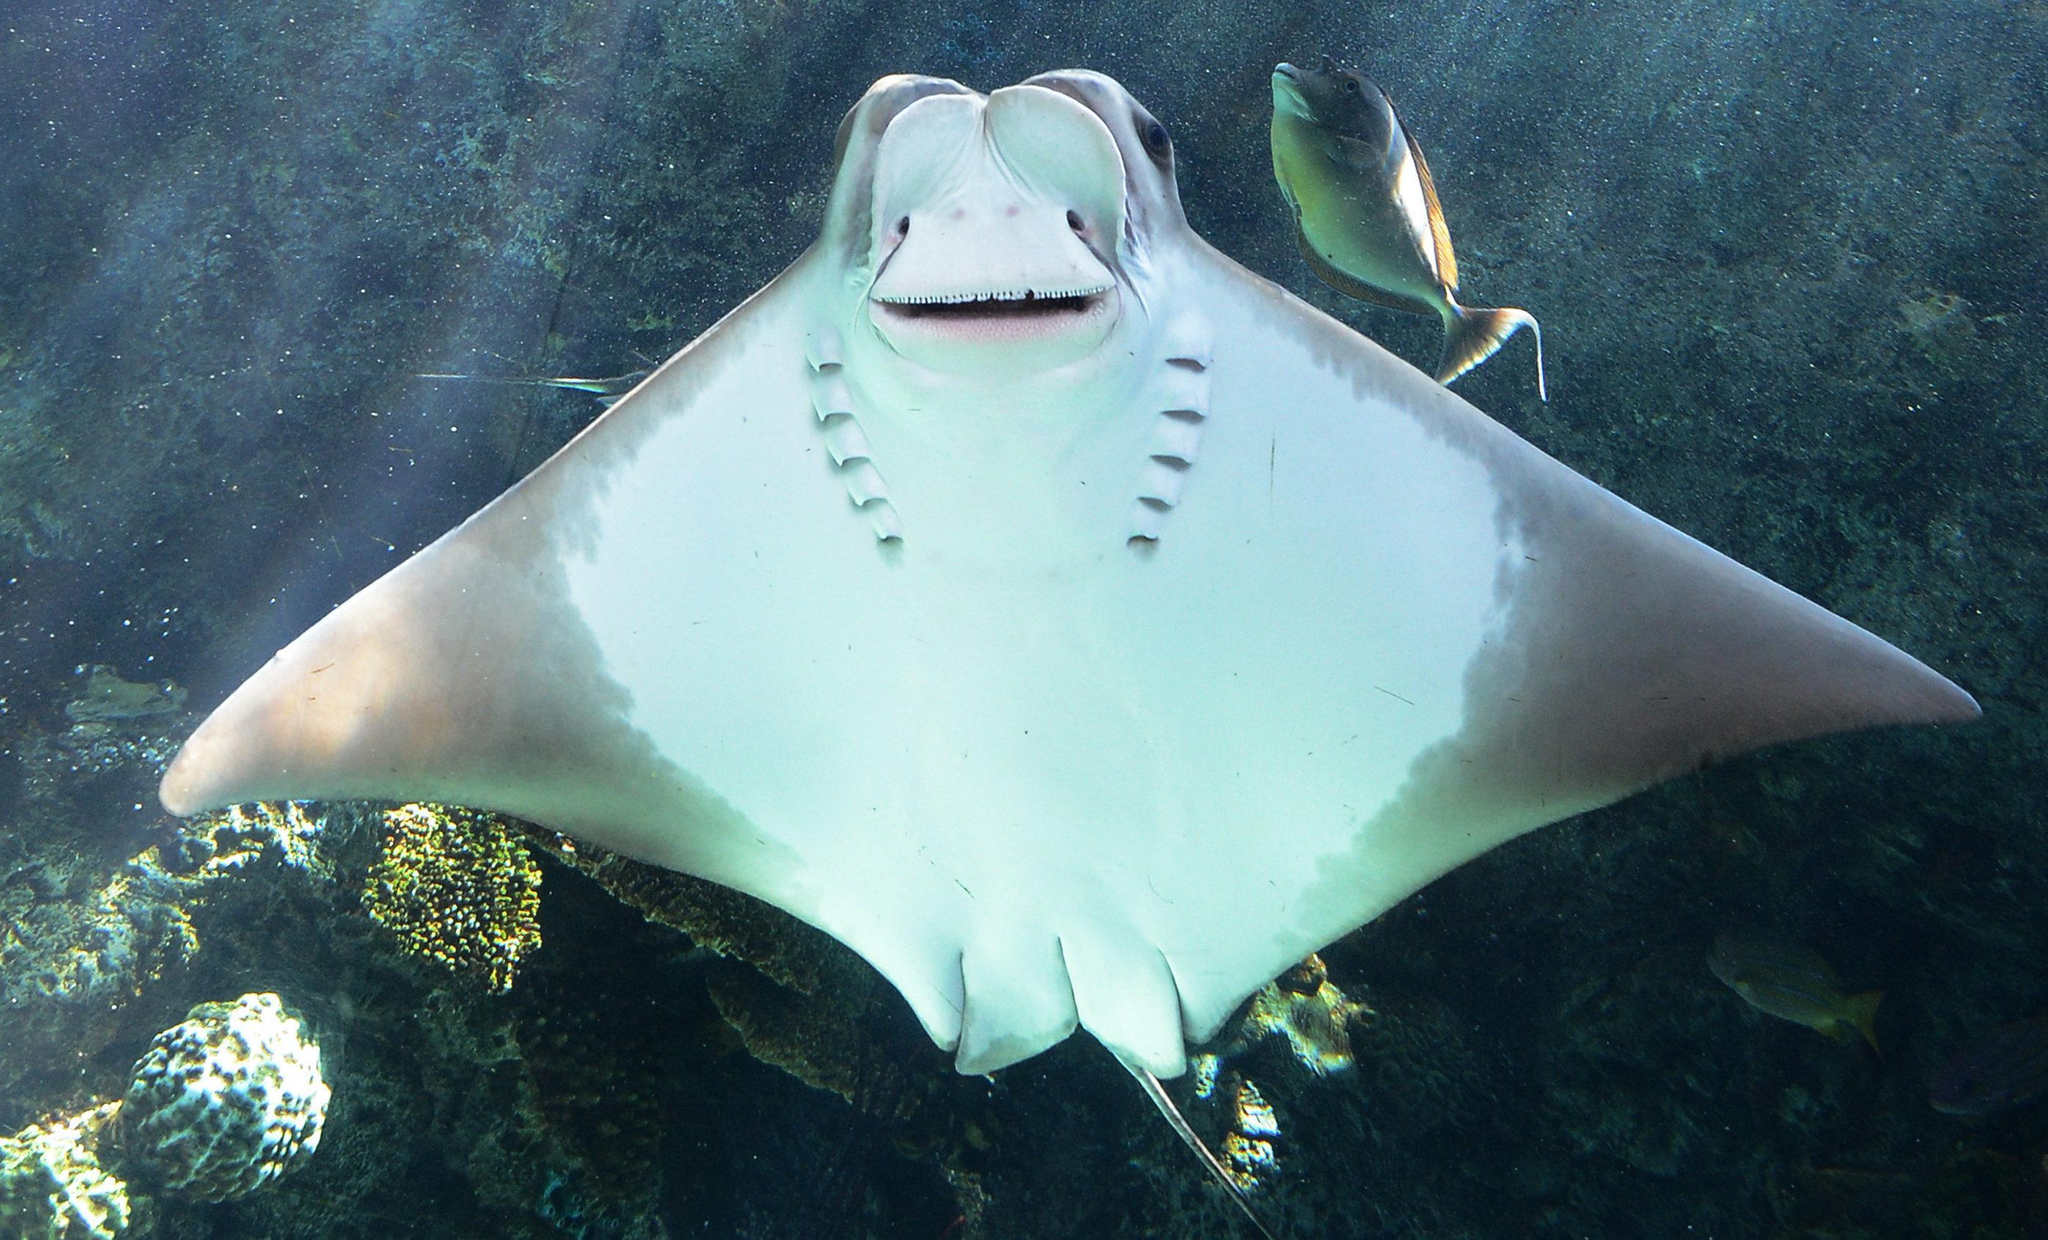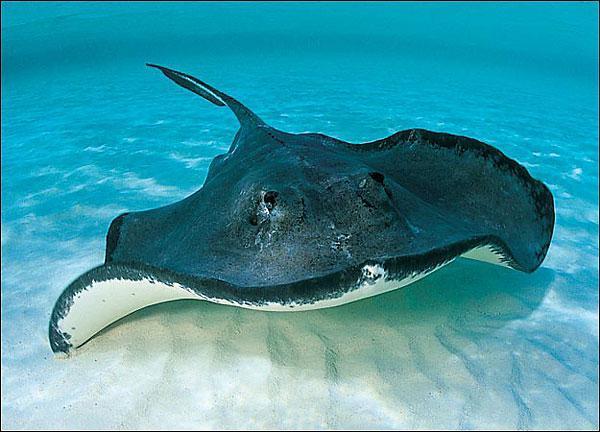The first image is the image on the left, the second image is the image on the right. Analyze the images presented: Is the assertion "Each image has exactly one ray." valid? Answer yes or no. Yes. 